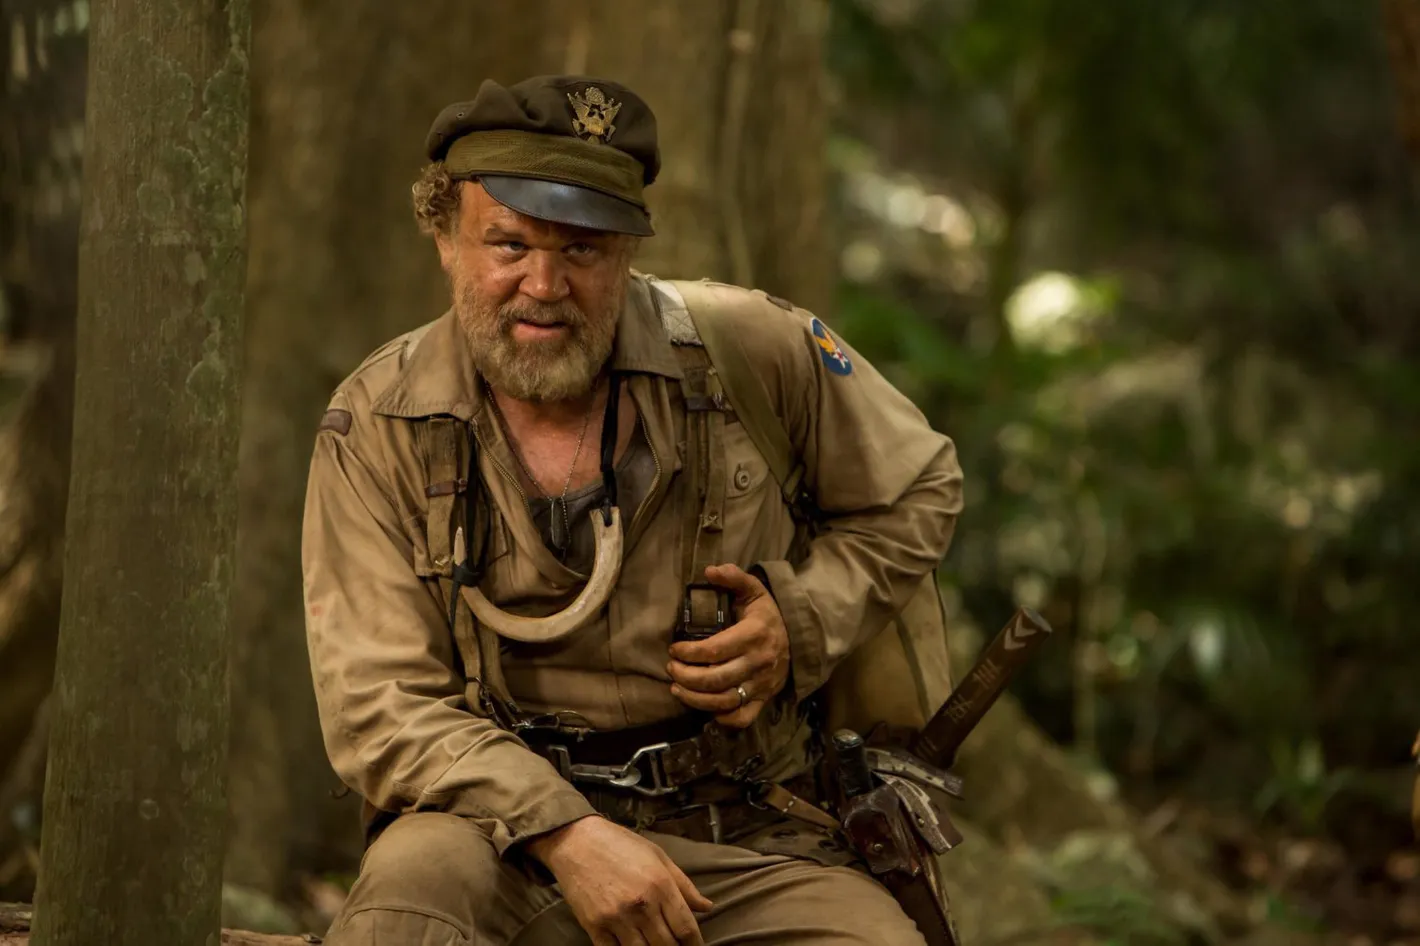What do you think the soldier might be contemplating in this scene? In this scene, the soldier might be contemplating the next steps in his mission, strategizing his movements to ensure he stays safe and completes his objectives successfully. The binoculars in his hands suggest he is on high alert, possibly keeping a lookout for enemy activity or searching for allies. The seriousness etched on his face implies that the stakes are high, and every decision he makes is crucial for his survival and that of his comrades. You mentioned high stakes. Could you elaborate on what kind of mission this might be? Given the intense focus and the rugged gear of the soldier, it's plausible that he is part of a reconnaissance mission deep within enemy territory. His primary objective could be gathering intelligence on enemy movements and fortifications. The isolated forest setting suggests that he’s in a strategic but dangerous location, where stealth and vigilance are of utmost importance. Recon missions of this nature often require the soldier to relay crucial information back to the main force, significantly influencing the outcome of larger military operations. The gravity of his expression also hints at the possibility of impending danger, making his mission one where both information and survival are key. 